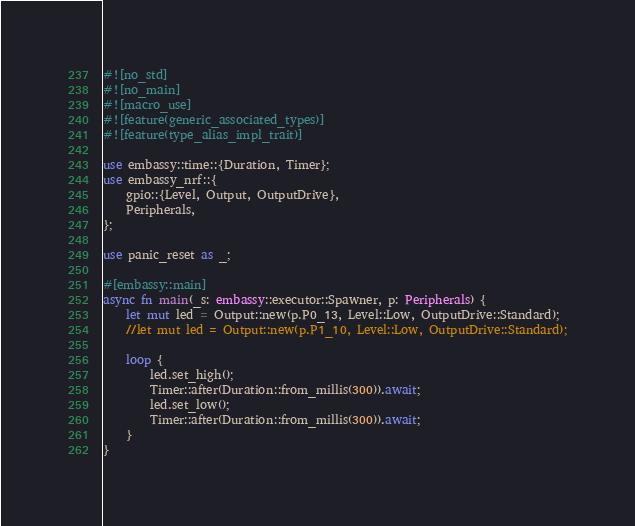Convert code to text. <code><loc_0><loc_0><loc_500><loc_500><_Rust_>#![no_std]
#![no_main]
#![macro_use]
#![feature(generic_associated_types)]
#![feature(type_alias_impl_trait)]

use embassy::time::{Duration, Timer};
use embassy_nrf::{
    gpio::{Level, Output, OutputDrive},
    Peripherals,
};

use panic_reset as _;

#[embassy::main]
async fn main(_s: embassy::executor::Spawner, p: Peripherals) {
    let mut led = Output::new(p.P0_13, Level::Low, OutputDrive::Standard);
    //let mut led = Output::new(p.P1_10, Level::Low, OutputDrive::Standard);

    loop {
        led.set_high();
        Timer::after(Duration::from_millis(300)).await;
        led.set_low();
        Timer::after(Duration::from_millis(300)).await;
    }
}
</code> 